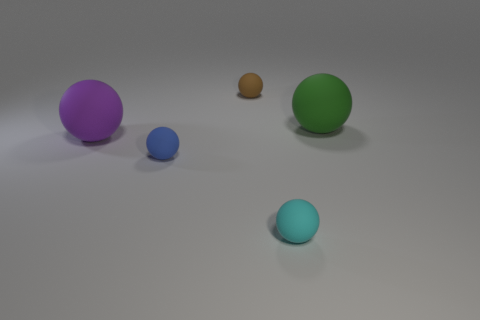Subtract all brown balls. How many balls are left? 4 Subtract all tiny blue matte spheres. How many spheres are left? 4 Subtract 2 balls. How many balls are left? 3 Subtract all red spheres. Subtract all cyan cylinders. How many spheres are left? 5 Add 5 brown spheres. How many objects exist? 10 Subtract all big matte objects. Subtract all brown rubber things. How many objects are left? 2 Add 5 small cyan balls. How many small cyan balls are left? 6 Add 2 brown matte things. How many brown matte things exist? 3 Subtract 1 purple spheres. How many objects are left? 4 